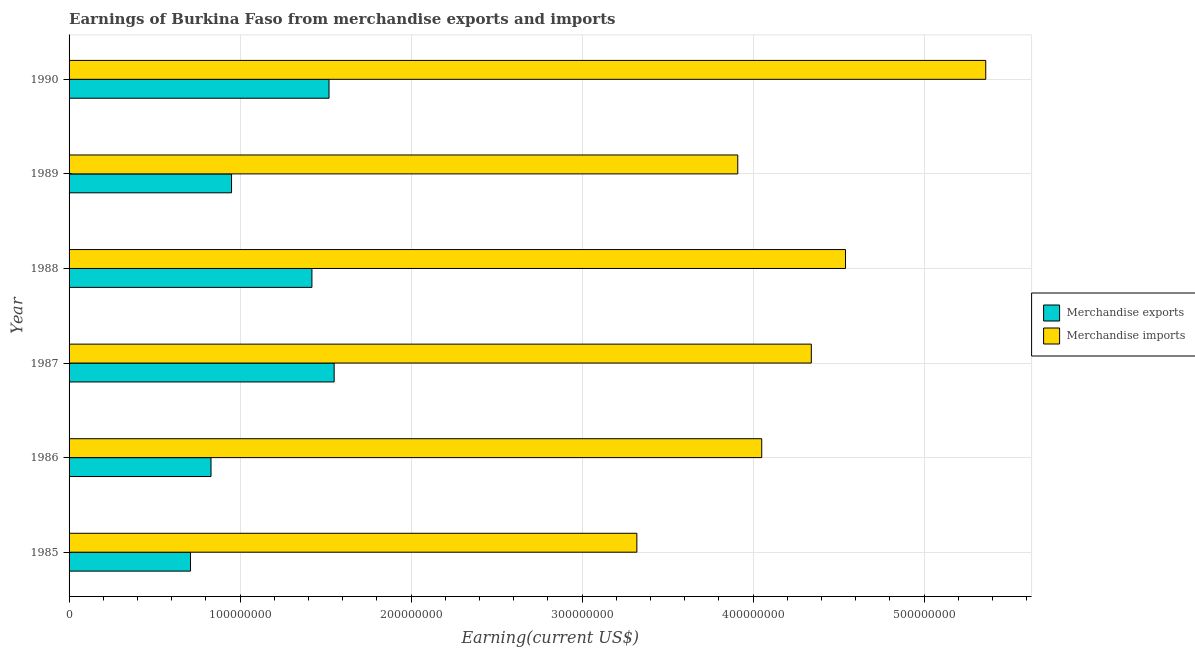Are the number of bars on each tick of the Y-axis equal?
Your answer should be compact. Yes. How many bars are there on the 3rd tick from the top?
Your answer should be very brief. 2. In how many cases, is the number of bars for a given year not equal to the number of legend labels?
Offer a very short reply. 0. What is the earnings from merchandise exports in 1986?
Provide a short and direct response. 8.30e+07. Across all years, what is the maximum earnings from merchandise exports?
Offer a terse response. 1.55e+08. Across all years, what is the minimum earnings from merchandise imports?
Provide a short and direct response. 3.32e+08. What is the total earnings from merchandise exports in the graph?
Ensure brevity in your answer.  6.98e+08. What is the difference between the earnings from merchandise imports in 1987 and that in 1990?
Your answer should be very brief. -1.02e+08. What is the difference between the earnings from merchandise exports in 1989 and the earnings from merchandise imports in 1986?
Provide a succinct answer. -3.10e+08. What is the average earnings from merchandise imports per year?
Keep it short and to the point. 4.25e+08. In the year 1989, what is the difference between the earnings from merchandise imports and earnings from merchandise exports?
Keep it short and to the point. 2.96e+08. In how many years, is the earnings from merchandise imports greater than 20000000 US$?
Keep it short and to the point. 6. What is the ratio of the earnings from merchandise imports in 1985 to that in 1989?
Provide a succinct answer. 0.85. What is the difference between the highest and the lowest earnings from merchandise imports?
Provide a short and direct response. 2.04e+08. In how many years, is the earnings from merchandise imports greater than the average earnings from merchandise imports taken over all years?
Give a very brief answer. 3. What does the 1st bar from the bottom in 1989 represents?
Offer a very short reply. Merchandise exports. What is the difference between two consecutive major ticks on the X-axis?
Your answer should be very brief. 1.00e+08. Are the values on the major ticks of X-axis written in scientific E-notation?
Your answer should be compact. No. Where does the legend appear in the graph?
Provide a succinct answer. Center right. What is the title of the graph?
Make the answer very short. Earnings of Burkina Faso from merchandise exports and imports. Does "Young" appear as one of the legend labels in the graph?
Keep it short and to the point. No. What is the label or title of the X-axis?
Your answer should be compact. Earning(current US$). What is the Earning(current US$) of Merchandise exports in 1985?
Provide a short and direct response. 7.10e+07. What is the Earning(current US$) in Merchandise imports in 1985?
Make the answer very short. 3.32e+08. What is the Earning(current US$) of Merchandise exports in 1986?
Offer a very short reply. 8.30e+07. What is the Earning(current US$) in Merchandise imports in 1986?
Offer a very short reply. 4.05e+08. What is the Earning(current US$) in Merchandise exports in 1987?
Make the answer very short. 1.55e+08. What is the Earning(current US$) in Merchandise imports in 1987?
Offer a terse response. 4.34e+08. What is the Earning(current US$) of Merchandise exports in 1988?
Provide a succinct answer. 1.42e+08. What is the Earning(current US$) of Merchandise imports in 1988?
Offer a very short reply. 4.54e+08. What is the Earning(current US$) in Merchandise exports in 1989?
Provide a short and direct response. 9.50e+07. What is the Earning(current US$) in Merchandise imports in 1989?
Give a very brief answer. 3.91e+08. What is the Earning(current US$) in Merchandise exports in 1990?
Make the answer very short. 1.52e+08. What is the Earning(current US$) of Merchandise imports in 1990?
Keep it short and to the point. 5.36e+08. Across all years, what is the maximum Earning(current US$) of Merchandise exports?
Your answer should be compact. 1.55e+08. Across all years, what is the maximum Earning(current US$) of Merchandise imports?
Make the answer very short. 5.36e+08. Across all years, what is the minimum Earning(current US$) of Merchandise exports?
Offer a terse response. 7.10e+07. Across all years, what is the minimum Earning(current US$) in Merchandise imports?
Provide a short and direct response. 3.32e+08. What is the total Earning(current US$) in Merchandise exports in the graph?
Provide a short and direct response. 6.98e+08. What is the total Earning(current US$) in Merchandise imports in the graph?
Offer a terse response. 2.55e+09. What is the difference between the Earning(current US$) of Merchandise exports in 1985 and that in 1986?
Give a very brief answer. -1.20e+07. What is the difference between the Earning(current US$) in Merchandise imports in 1985 and that in 1986?
Your answer should be very brief. -7.30e+07. What is the difference between the Earning(current US$) of Merchandise exports in 1985 and that in 1987?
Give a very brief answer. -8.40e+07. What is the difference between the Earning(current US$) of Merchandise imports in 1985 and that in 1987?
Provide a short and direct response. -1.02e+08. What is the difference between the Earning(current US$) of Merchandise exports in 1985 and that in 1988?
Give a very brief answer. -7.10e+07. What is the difference between the Earning(current US$) in Merchandise imports in 1985 and that in 1988?
Provide a short and direct response. -1.22e+08. What is the difference between the Earning(current US$) of Merchandise exports in 1985 and that in 1989?
Your answer should be compact. -2.40e+07. What is the difference between the Earning(current US$) of Merchandise imports in 1985 and that in 1989?
Make the answer very short. -5.90e+07. What is the difference between the Earning(current US$) in Merchandise exports in 1985 and that in 1990?
Offer a terse response. -8.10e+07. What is the difference between the Earning(current US$) of Merchandise imports in 1985 and that in 1990?
Give a very brief answer. -2.04e+08. What is the difference between the Earning(current US$) in Merchandise exports in 1986 and that in 1987?
Your response must be concise. -7.20e+07. What is the difference between the Earning(current US$) in Merchandise imports in 1986 and that in 1987?
Ensure brevity in your answer.  -2.90e+07. What is the difference between the Earning(current US$) of Merchandise exports in 1986 and that in 1988?
Offer a very short reply. -5.90e+07. What is the difference between the Earning(current US$) of Merchandise imports in 1986 and that in 1988?
Your answer should be compact. -4.90e+07. What is the difference between the Earning(current US$) of Merchandise exports in 1986 and that in 1989?
Offer a very short reply. -1.20e+07. What is the difference between the Earning(current US$) of Merchandise imports in 1986 and that in 1989?
Your answer should be very brief. 1.40e+07. What is the difference between the Earning(current US$) of Merchandise exports in 1986 and that in 1990?
Ensure brevity in your answer.  -6.90e+07. What is the difference between the Earning(current US$) in Merchandise imports in 1986 and that in 1990?
Offer a terse response. -1.31e+08. What is the difference between the Earning(current US$) of Merchandise exports in 1987 and that in 1988?
Keep it short and to the point. 1.30e+07. What is the difference between the Earning(current US$) of Merchandise imports in 1987 and that in 1988?
Ensure brevity in your answer.  -2.00e+07. What is the difference between the Earning(current US$) of Merchandise exports in 1987 and that in 1989?
Your answer should be very brief. 6.00e+07. What is the difference between the Earning(current US$) of Merchandise imports in 1987 and that in 1989?
Provide a short and direct response. 4.30e+07. What is the difference between the Earning(current US$) in Merchandise exports in 1987 and that in 1990?
Your answer should be compact. 3.00e+06. What is the difference between the Earning(current US$) of Merchandise imports in 1987 and that in 1990?
Give a very brief answer. -1.02e+08. What is the difference between the Earning(current US$) in Merchandise exports in 1988 and that in 1989?
Your response must be concise. 4.70e+07. What is the difference between the Earning(current US$) of Merchandise imports in 1988 and that in 1989?
Ensure brevity in your answer.  6.30e+07. What is the difference between the Earning(current US$) of Merchandise exports in 1988 and that in 1990?
Offer a terse response. -1.00e+07. What is the difference between the Earning(current US$) in Merchandise imports in 1988 and that in 1990?
Your response must be concise. -8.20e+07. What is the difference between the Earning(current US$) in Merchandise exports in 1989 and that in 1990?
Provide a short and direct response. -5.70e+07. What is the difference between the Earning(current US$) in Merchandise imports in 1989 and that in 1990?
Your answer should be very brief. -1.45e+08. What is the difference between the Earning(current US$) of Merchandise exports in 1985 and the Earning(current US$) of Merchandise imports in 1986?
Offer a terse response. -3.34e+08. What is the difference between the Earning(current US$) of Merchandise exports in 1985 and the Earning(current US$) of Merchandise imports in 1987?
Ensure brevity in your answer.  -3.63e+08. What is the difference between the Earning(current US$) of Merchandise exports in 1985 and the Earning(current US$) of Merchandise imports in 1988?
Provide a short and direct response. -3.83e+08. What is the difference between the Earning(current US$) of Merchandise exports in 1985 and the Earning(current US$) of Merchandise imports in 1989?
Your response must be concise. -3.20e+08. What is the difference between the Earning(current US$) in Merchandise exports in 1985 and the Earning(current US$) in Merchandise imports in 1990?
Provide a succinct answer. -4.65e+08. What is the difference between the Earning(current US$) in Merchandise exports in 1986 and the Earning(current US$) in Merchandise imports in 1987?
Keep it short and to the point. -3.51e+08. What is the difference between the Earning(current US$) of Merchandise exports in 1986 and the Earning(current US$) of Merchandise imports in 1988?
Ensure brevity in your answer.  -3.71e+08. What is the difference between the Earning(current US$) of Merchandise exports in 1986 and the Earning(current US$) of Merchandise imports in 1989?
Give a very brief answer. -3.08e+08. What is the difference between the Earning(current US$) in Merchandise exports in 1986 and the Earning(current US$) in Merchandise imports in 1990?
Give a very brief answer. -4.53e+08. What is the difference between the Earning(current US$) in Merchandise exports in 1987 and the Earning(current US$) in Merchandise imports in 1988?
Ensure brevity in your answer.  -2.99e+08. What is the difference between the Earning(current US$) in Merchandise exports in 1987 and the Earning(current US$) in Merchandise imports in 1989?
Offer a terse response. -2.36e+08. What is the difference between the Earning(current US$) in Merchandise exports in 1987 and the Earning(current US$) in Merchandise imports in 1990?
Provide a succinct answer. -3.81e+08. What is the difference between the Earning(current US$) of Merchandise exports in 1988 and the Earning(current US$) of Merchandise imports in 1989?
Your answer should be very brief. -2.49e+08. What is the difference between the Earning(current US$) in Merchandise exports in 1988 and the Earning(current US$) in Merchandise imports in 1990?
Give a very brief answer. -3.94e+08. What is the difference between the Earning(current US$) in Merchandise exports in 1989 and the Earning(current US$) in Merchandise imports in 1990?
Your response must be concise. -4.41e+08. What is the average Earning(current US$) of Merchandise exports per year?
Give a very brief answer. 1.16e+08. What is the average Earning(current US$) in Merchandise imports per year?
Give a very brief answer. 4.25e+08. In the year 1985, what is the difference between the Earning(current US$) of Merchandise exports and Earning(current US$) of Merchandise imports?
Make the answer very short. -2.61e+08. In the year 1986, what is the difference between the Earning(current US$) of Merchandise exports and Earning(current US$) of Merchandise imports?
Offer a terse response. -3.22e+08. In the year 1987, what is the difference between the Earning(current US$) in Merchandise exports and Earning(current US$) in Merchandise imports?
Your answer should be very brief. -2.79e+08. In the year 1988, what is the difference between the Earning(current US$) in Merchandise exports and Earning(current US$) in Merchandise imports?
Give a very brief answer. -3.12e+08. In the year 1989, what is the difference between the Earning(current US$) in Merchandise exports and Earning(current US$) in Merchandise imports?
Offer a very short reply. -2.96e+08. In the year 1990, what is the difference between the Earning(current US$) of Merchandise exports and Earning(current US$) of Merchandise imports?
Ensure brevity in your answer.  -3.84e+08. What is the ratio of the Earning(current US$) of Merchandise exports in 1985 to that in 1986?
Make the answer very short. 0.86. What is the ratio of the Earning(current US$) of Merchandise imports in 1985 to that in 1986?
Provide a short and direct response. 0.82. What is the ratio of the Earning(current US$) in Merchandise exports in 1985 to that in 1987?
Your answer should be very brief. 0.46. What is the ratio of the Earning(current US$) in Merchandise imports in 1985 to that in 1987?
Give a very brief answer. 0.77. What is the ratio of the Earning(current US$) of Merchandise exports in 1985 to that in 1988?
Provide a succinct answer. 0.5. What is the ratio of the Earning(current US$) of Merchandise imports in 1985 to that in 1988?
Your answer should be compact. 0.73. What is the ratio of the Earning(current US$) of Merchandise exports in 1985 to that in 1989?
Offer a very short reply. 0.75. What is the ratio of the Earning(current US$) of Merchandise imports in 1985 to that in 1989?
Your answer should be compact. 0.85. What is the ratio of the Earning(current US$) in Merchandise exports in 1985 to that in 1990?
Provide a short and direct response. 0.47. What is the ratio of the Earning(current US$) of Merchandise imports in 1985 to that in 1990?
Give a very brief answer. 0.62. What is the ratio of the Earning(current US$) of Merchandise exports in 1986 to that in 1987?
Your response must be concise. 0.54. What is the ratio of the Earning(current US$) in Merchandise imports in 1986 to that in 1987?
Provide a succinct answer. 0.93. What is the ratio of the Earning(current US$) of Merchandise exports in 1986 to that in 1988?
Offer a very short reply. 0.58. What is the ratio of the Earning(current US$) in Merchandise imports in 1986 to that in 1988?
Make the answer very short. 0.89. What is the ratio of the Earning(current US$) of Merchandise exports in 1986 to that in 1989?
Your response must be concise. 0.87. What is the ratio of the Earning(current US$) in Merchandise imports in 1986 to that in 1989?
Make the answer very short. 1.04. What is the ratio of the Earning(current US$) of Merchandise exports in 1986 to that in 1990?
Provide a short and direct response. 0.55. What is the ratio of the Earning(current US$) in Merchandise imports in 1986 to that in 1990?
Your answer should be compact. 0.76. What is the ratio of the Earning(current US$) in Merchandise exports in 1987 to that in 1988?
Your response must be concise. 1.09. What is the ratio of the Earning(current US$) in Merchandise imports in 1987 to that in 1988?
Your answer should be very brief. 0.96. What is the ratio of the Earning(current US$) in Merchandise exports in 1987 to that in 1989?
Give a very brief answer. 1.63. What is the ratio of the Earning(current US$) of Merchandise imports in 1987 to that in 1989?
Offer a terse response. 1.11. What is the ratio of the Earning(current US$) in Merchandise exports in 1987 to that in 1990?
Your answer should be very brief. 1.02. What is the ratio of the Earning(current US$) of Merchandise imports in 1987 to that in 1990?
Offer a terse response. 0.81. What is the ratio of the Earning(current US$) of Merchandise exports in 1988 to that in 1989?
Give a very brief answer. 1.49. What is the ratio of the Earning(current US$) of Merchandise imports in 1988 to that in 1989?
Offer a very short reply. 1.16. What is the ratio of the Earning(current US$) of Merchandise exports in 1988 to that in 1990?
Ensure brevity in your answer.  0.93. What is the ratio of the Earning(current US$) of Merchandise imports in 1988 to that in 1990?
Offer a terse response. 0.85. What is the ratio of the Earning(current US$) in Merchandise exports in 1989 to that in 1990?
Your answer should be compact. 0.62. What is the ratio of the Earning(current US$) in Merchandise imports in 1989 to that in 1990?
Your response must be concise. 0.73. What is the difference between the highest and the second highest Earning(current US$) of Merchandise exports?
Keep it short and to the point. 3.00e+06. What is the difference between the highest and the second highest Earning(current US$) in Merchandise imports?
Your response must be concise. 8.20e+07. What is the difference between the highest and the lowest Earning(current US$) of Merchandise exports?
Ensure brevity in your answer.  8.40e+07. What is the difference between the highest and the lowest Earning(current US$) in Merchandise imports?
Make the answer very short. 2.04e+08. 